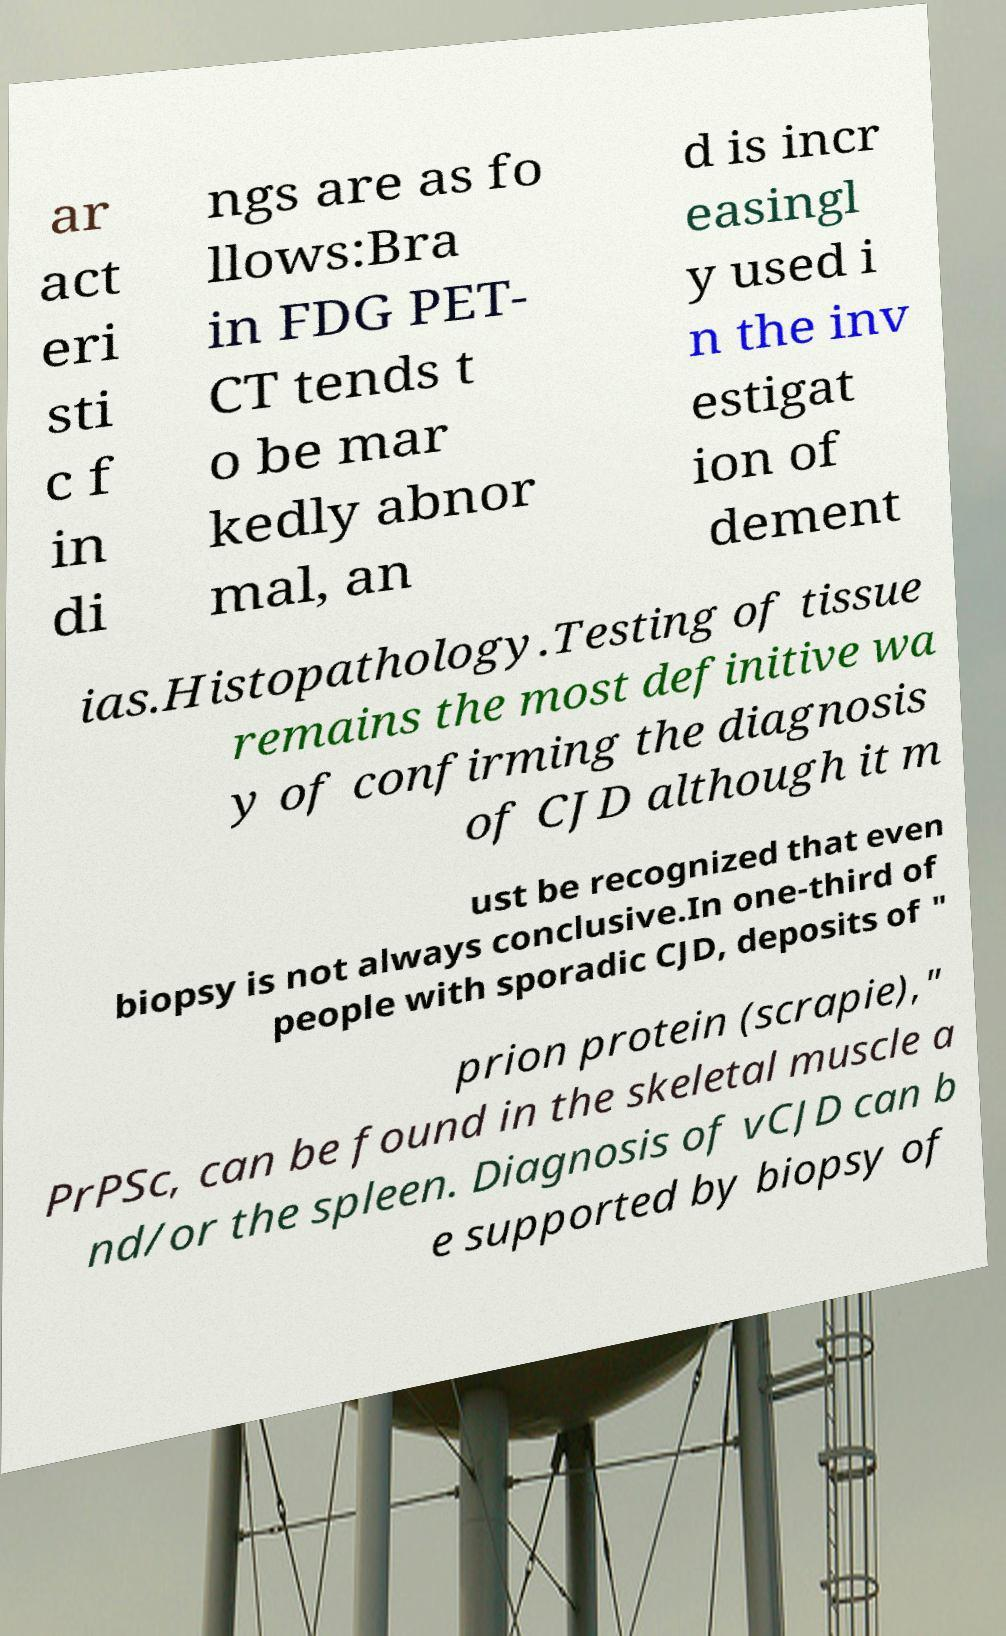Could you extract and type out the text from this image? ar act eri sti c f in di ngs are as fo llows:Bra in FDG PET- CT tends t o be mar kedly abnor mal, an d is incr easingl y used i n the inv estigat ion of dement ias.Histopathology.Testing of tissue remains the most definitive wa y of confirming the diagnosis of CJD although it m ust be recognized that even biopsy is not always conclusive.In one-third of people with sporadic CJD, deposits of " prion protein (scrapie)," PrPSc, can be found in the skeletal muscle a nd/or the spleen. Diagnosis of vCJD can b e supported by biopsy of 